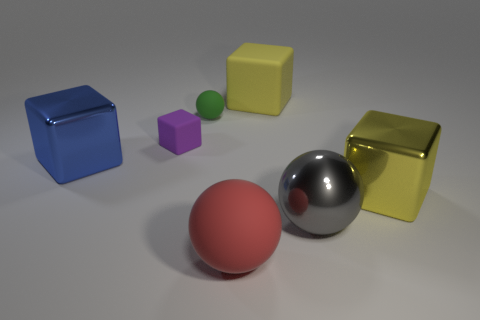What color is the metallic thing that is on the right side of the big sphere behind the rubber thing that is in front of the gray metal sphere?
Offer a very short reply. Yellow. There is a large matte object that is to the right of the large red ball; are there any yellow blocks in front of it?
Your response must be concise. Yes. Is the shape of the rubber thing in front of the blue metallic cube the same as  the big gray object?
Your response must be concise. Yes. How many spheres are rubber objects or tiny matte things?
Your response must be concise. 2. How many small blocks are there?
Ensure brevity in your answer.  1. What is the size of the rubber cube that is right of the rubber sphere that is in front of the purple thing?
Offer a terse response. Large. What number of other objects are there of the same size as the yellow metallic cube?
Offer a very short reply. 4. What number of big matte balls are to the right of the large blue metallic thing?
Your answer should be compact. 1. What size is the metallic ball?
Your response must be concise. Large. Is the yellow thing that is on the left side of the large yellow metallic thing made of the same material as the large block that is in front of the blue shiny block?
Provide a succinct answer. No. 